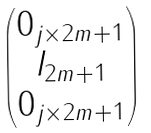<formula> <loc_0><loc_0><loc_500><loc_500>\begin{pmatrix} 0 _ { j \times 2 m + 1 } \\ I _ { 2 m + 1 } \\ 0 _ { j \times 2 m + 1 } \end{pmatrix}</formula> 